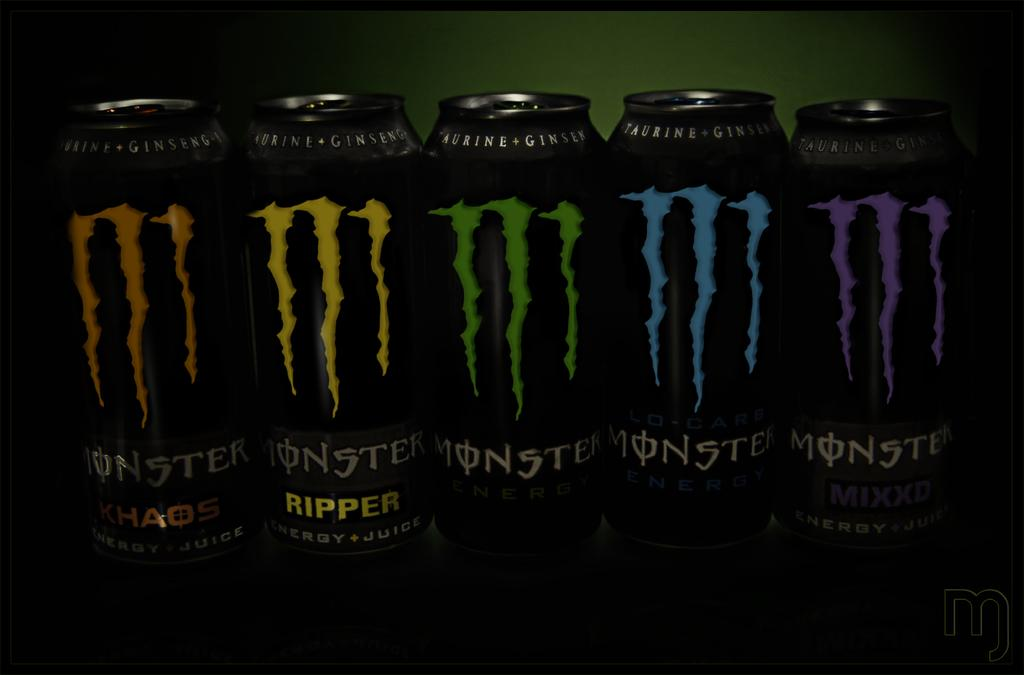<image>
Summarize the visual content of the image. Five different types of Monster energy drinks sit on a table. 